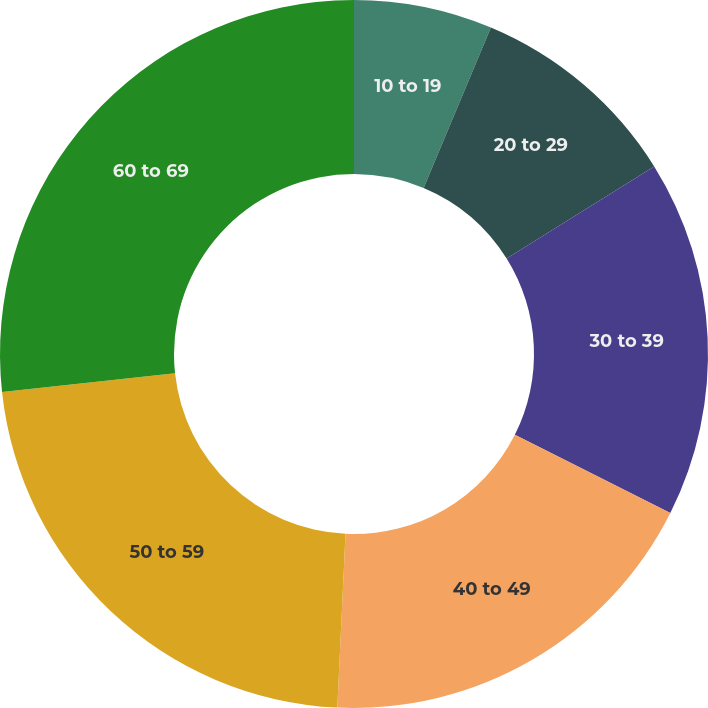Convert chart to OTSL. <chart><loc_0><loc_0><loc_500><loc_500><pie_chart><fcel>10 to 19<fcel>20 to 29<fcel>30 to 39<fcel>40 to 49<fcel>50 to 59<fcel>60 to 69<nl><fcel>6.32%<fcel>9.79%<fcel>16.3%<fcel>18.34%<fcel>22.54%<fcel>26.71%<nl></chart> 